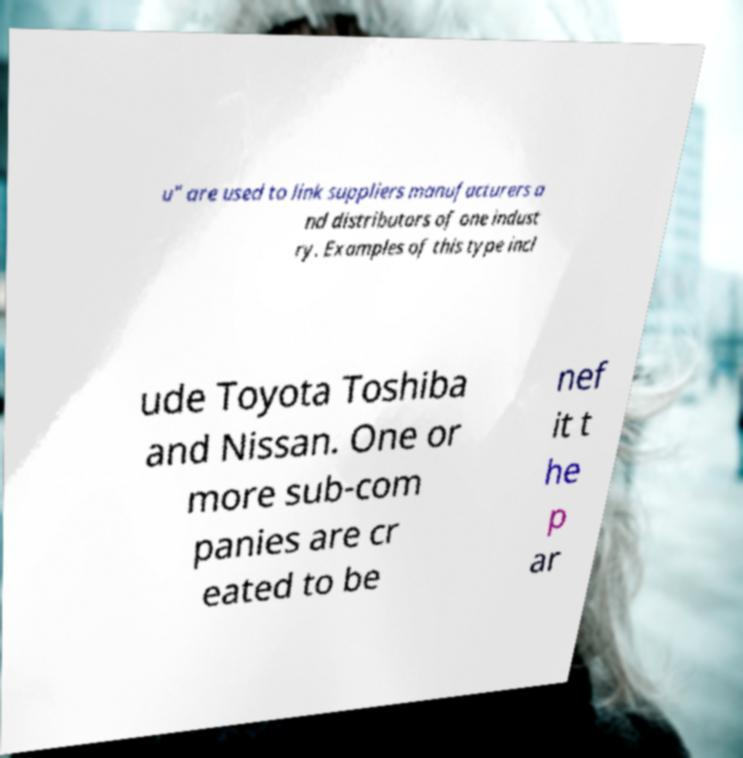What messages or text are displayed in this image? I need them in a readable, typed format. u" are used to link suppliers manufacturers a nd distributors of one indust ry. Examples of this type incl ude Toyota Toshiba and Nissan. One or more sub-com panies are cr eated to be nef it t he p ar 